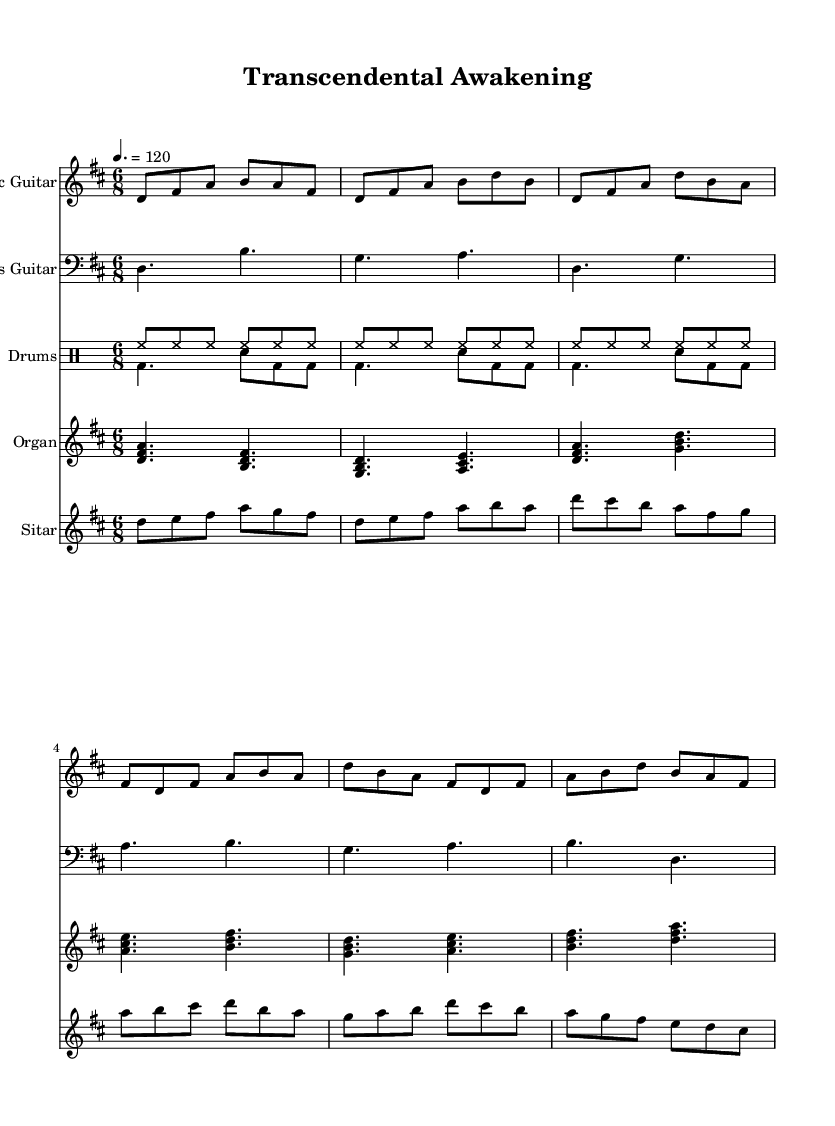What is the key signature of this music? The key signature is indicated at the beginning of the staff and shows two sharps, which are F sharp and C sharp. This means the piece is in D major.
Answer: D major What is the time signature of the piece? The time signature is shown at the beginning of the staff as a fraction, and in this case, it shows 6 over 8. This indicates that there are six eighth notes in each measure.
Answer: 6/8 What is the tempo marking for this piece? The tempo marking is indicated in the score as '4. = 120', meaning that a quarter note is played at 120 beats per minute, suggesting an upbeat feel appropriate for rock music.
Answer: 120 How many instruments are involved in this score? The score includes five different staves, representing five different instruments: Electric Guitar, Bass Guitar, Drums, Organ, and Sitar. Thus, there are five instruments involved.
Answer: Five What type of rhythmic pattern is used in the drums? The drums demonstrate a basic 6/8 pattern with syncopation, which is typical in rock music to create a driving rhythm. This can be seen by the arrangement of the bass drum and snare.
Answer: Syncopation What instrument is played using melodic lines inspired by Eastern music? The Sitar part contains a melodic line that reflects the traditional playing style of the sitar, using exotic scales and ornamentation typical of Eastern music, thus it's representative of that instrument.
Answer: Sitar What chord progression is present in the organ part? The chord progression shows major chords, starting with D major, F sharp minor, A major, and continuing through related major and minor chords that contribute to the transcendental feel typical of psychedelic rock music.
Answer: D, F sharp, A 